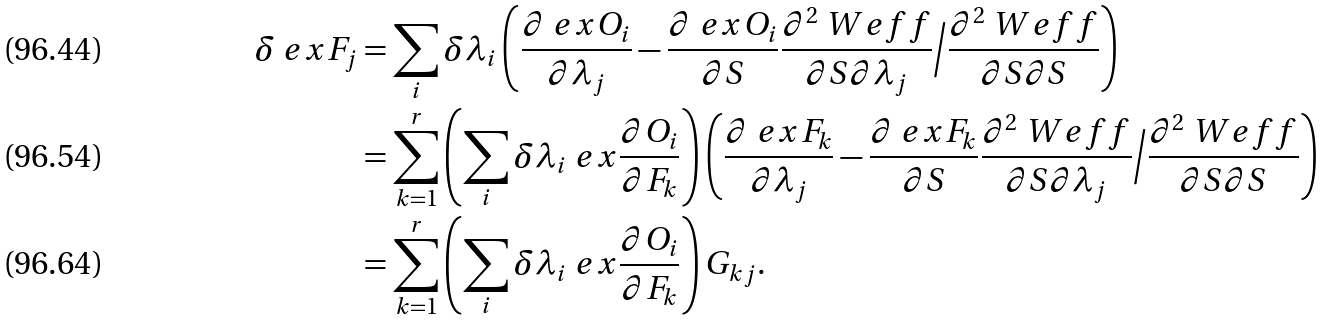<formula> <loc_0><loc_0><loc_500><loc_500>\delta \ e x { F _ { j } } & = \sum _ { i } \delta \lambda _ { i } \left ( \frac { \partial \ e x { O _ { i } } } { \partial \lambda _ { j } } - \frac { \partial \ e x { O _ { i } } } { \partial S } \frac { \partial ^ { 2 } \ W { e f f } } { \partial S \partial \lambda _ { j } } \Big / \frac { \partial ^ { 2 } \ W { e f f } } { \partial S \partial S } \right ) \\ & = \sum _ { k = 1 } ^ { r } \left ( \sum _ { i } \delta \lambda _ { i } \ e x { \frac { \partial { O _ { i } } } { \partial { F _ { k } } } } \right ) \left ( \frac { \partial \ e x { F _ { k } } } { \partial \lambda _ { j } } - \frac { \partial \ e x { F _ { k } } } { \partial S } \frac { \partial ^ { 2 } \ W { e f f } } { \partial S \partial \lambda _ { j } } \Big / \frac { \partial ^ { 2 } \ W { e f f } } { \partial S \partial S } \right ) \\ & = \sum _ { k = 1 } ^ { r } \left ( \sum _ { i } \delta \lambda _ { i } \ e x { \frac { \partial { O _ { i } } } { \partial { F _ { k } } } } \right ) G _ { k j } .</formula> 